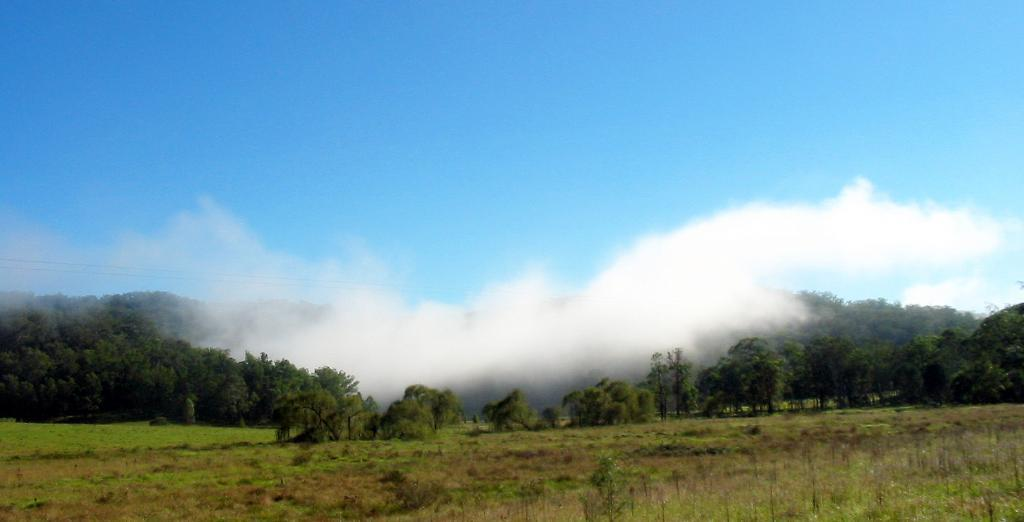What type of vegetation can be seen in the image? There are trees and plants visible in the image. What natural phenomenon is present in the image? There is fog in the image. What type of ground cover is visible in the image? There is grass visible in the image. What part of the natural environment is visible in the image? The sky is visible in the image. What type of office furniture can be seen in the image? There is no office furniture present in the image; it features natural elements such as trees, plants, fog, grass, and the sky. What type of mass is visible in the image? There is no mass present in the image; it features natural elements such as trees, plants, fog, grass, and the sky. 